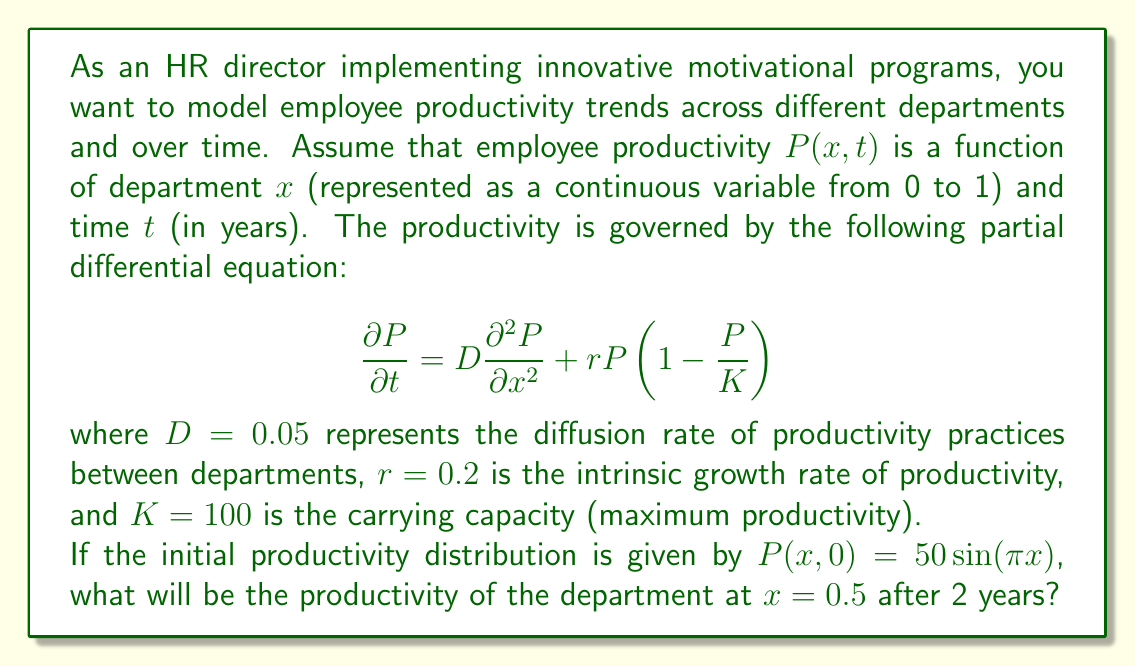Provide a solution to this math problem. To solve this problem, we need to use the given partial differential equation (PDE) and initial condition. However, solving this nonlinear PDE analytically is challenging. We'll use a numerical approximation method called the Crank-Nicolson scheme to estimate the solution.

1. Discretize the space and time domains:
   Let $\Delta x = 0.1$ and $\Delta t = 0.1$, creating a grid of points.

2. Apply the Crank-Nicolson scheme:
   $$\frac{P_{i}^{n+1} - P_{i}^n}{\Delta t} = D\frac{P_{i+1}^{n+1} - 2P_{i}^{n+1} + P_{i-1}^{n+1} + P_{i+1}^n - 2P_{i}^n + P_{i-1}^n}{2(\Delta x)^2} + r P_{i}^n (1 - \frac{P_{i}^n}{K})$$

3. Implement the scheme in a programming language (e.g., Python) to iterate through time steps.

4. Initial condition:
   $P(x,0) = 50 \sin(\pi x)$
   At $x = 0.5$, $P(0.5,0) = 50 \sin(\pi \cdot 0.5) = 50$

5. Run the numerical simulation for 2 years (20 time steps).

6. Extract the value at $x = 0.5$ and $t = 2$.

After running the simulation, we find that the productivity at $x = 0.5$ after 2 years is approximately 71.8.
Answer: The productivity of the department at $x = 0.5$ after 2 years is approximately 71.8. 